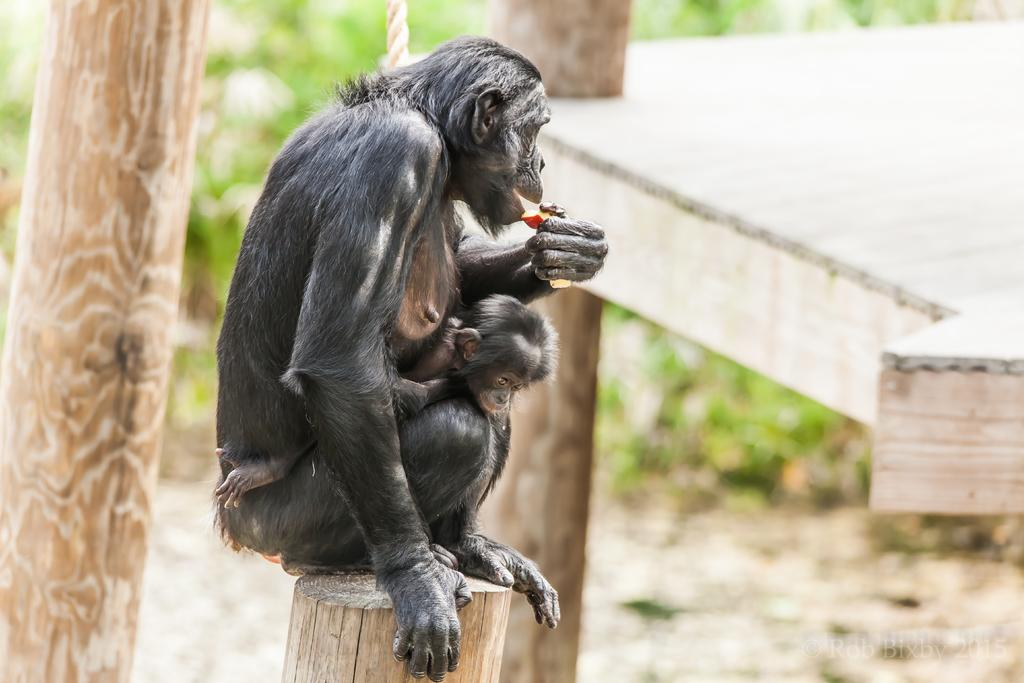How many chimpanzees are in the image? There are two chimpanzees in the image. Where are the chimpanzees located? The chimpanzees are on a wooden pole in the image. What type of natural elements can be seen in the image? The bark of trees and plants are visible in the image. What type of spoon can be seen in the image? There is no spoon present in the image. How does the earthquake affect the chimpanzees in the image? There is no earthquake depicted in the image, so its effects on the chimpanzees cannot be determined. 